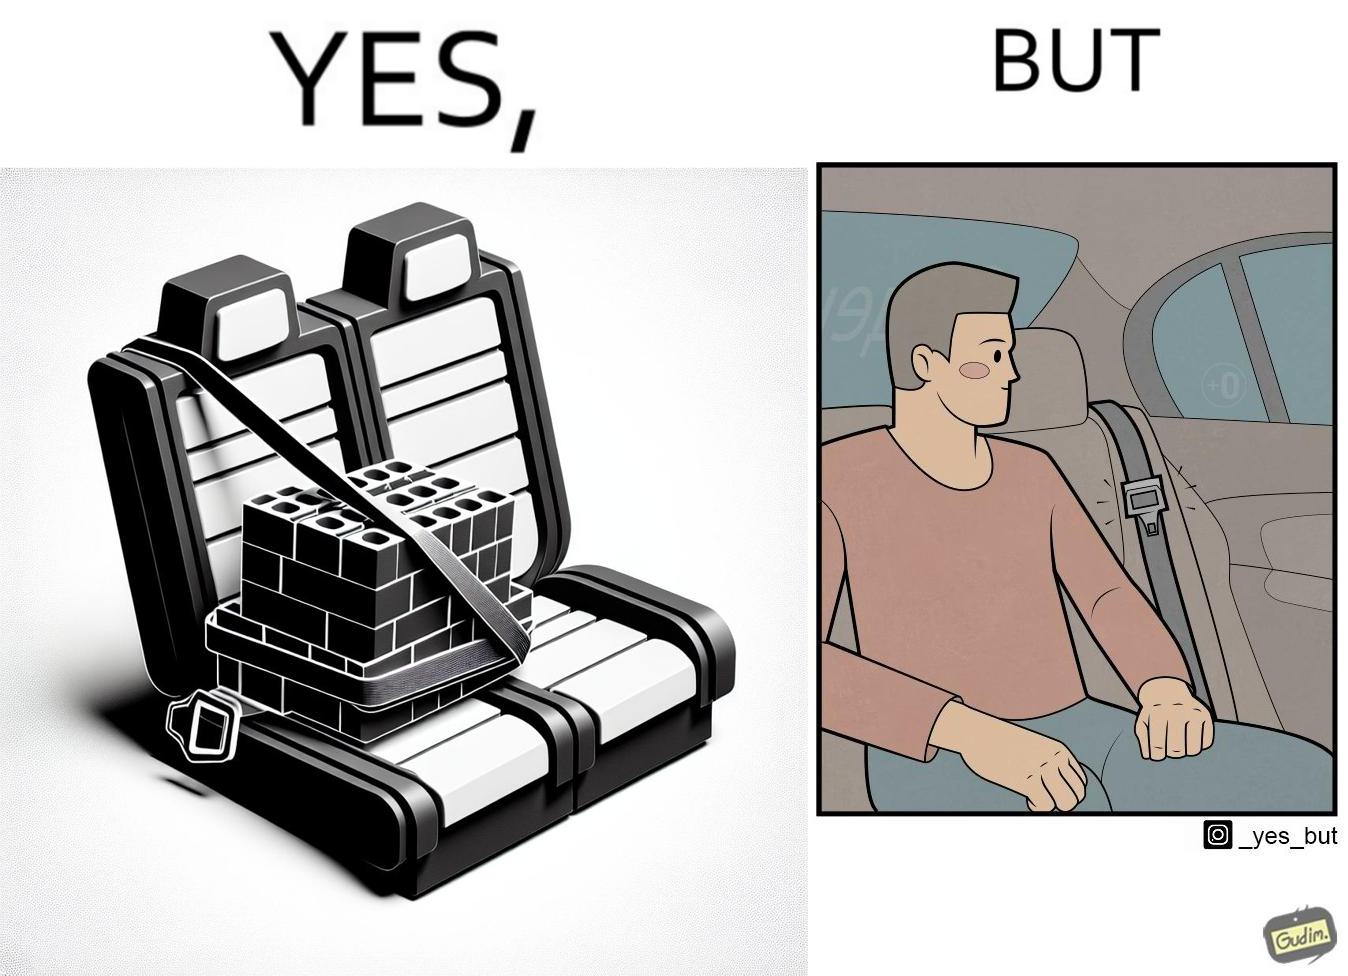Why is this image considered satirical? The image is ironical, as an inanimate box of building blocks has been secured by the seatbelt in the backseat of a car, while a person sitting in the backseat is not wearing the seatbelt, while the person would actually need the seatbelt in case there is an accident. 